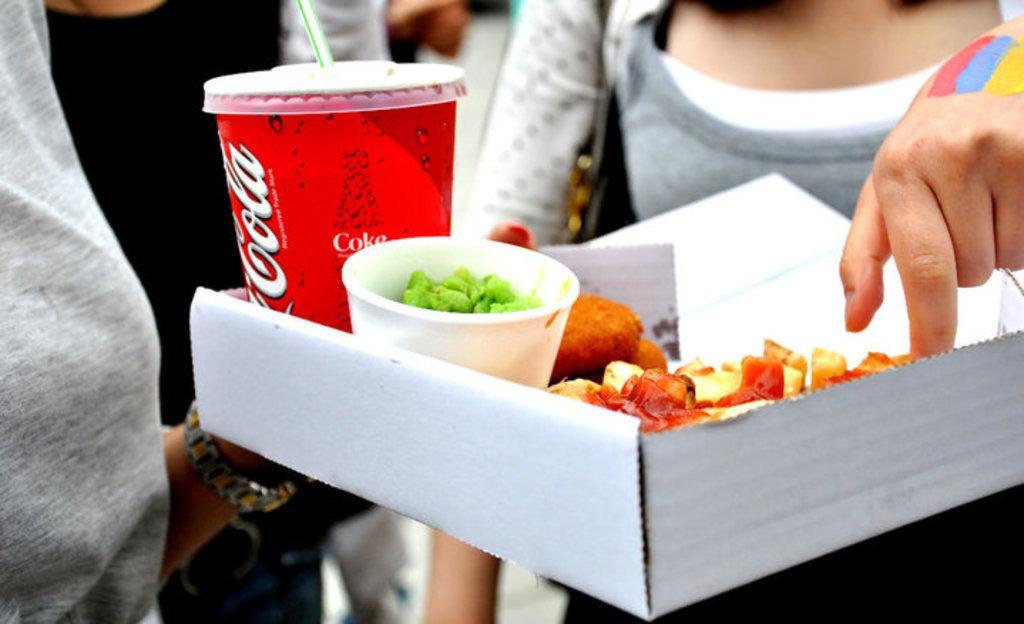Could you give a brief overview of what you see in this image? In this picture we can see the group of people and on the left we can see a person holding a box containing the glass of drink and the food items and we can see the sling bag and some other items. 